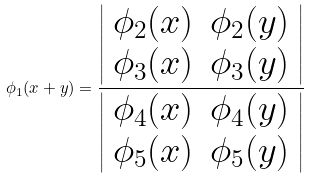Convert formula to latex. <formula><loc_0><loc_0><loc_500><loc_500>\phi _ { 1 } ( x + y ) = \frac { \left | \begin{array} { c c } \phi _ { 2 } ( x ) & \phi _ { 2 } ( y ) \\ \phi _ { 3 } ( x ) & \phi _ { 3 } ( y ) \\ \end{array} \right | } { \left | \begin{array} { c c } \phi _ { 4 } ( x ) & \phi _ { 4 } ( y ) \\ \phi _ { 5 } ( x ) & \phi _ { 5 } ( y ) \\ \end{array} \right | }</formula> 